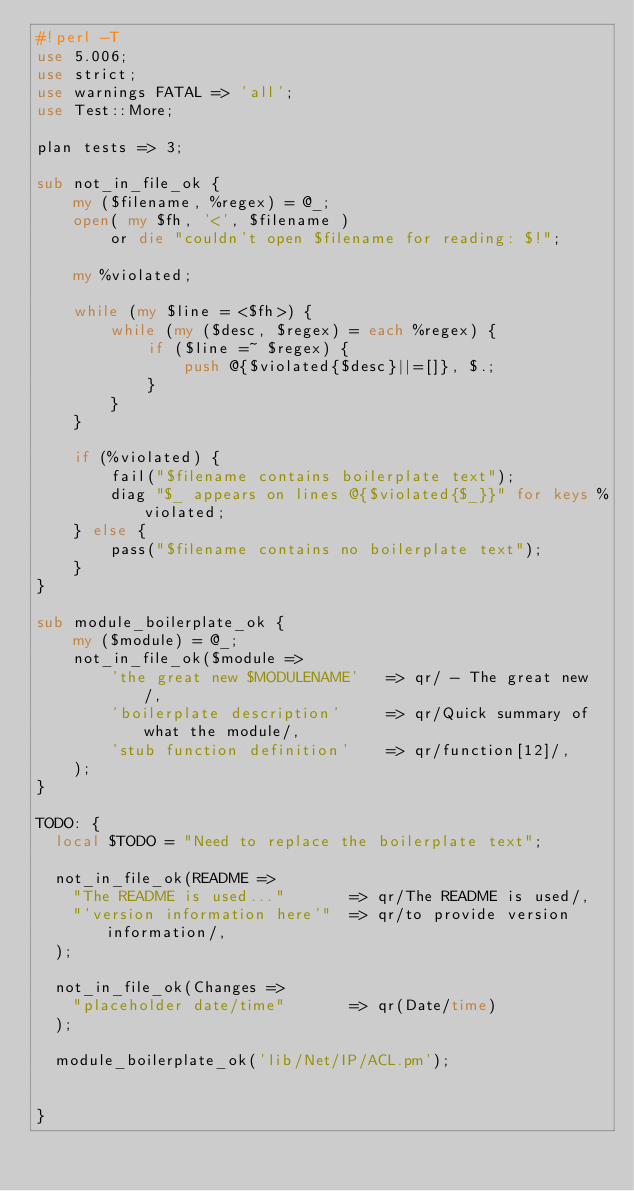<code> <loc_0><loc_0><loc_500><loc_500><_Perl_>#!perl -T
use 5.006;
use strict;
use warnings FATAL => 'all';
use Test::More;

plan tests => 3;

sub not_in_file_ok {
    my ($filename, %regex) = @_;
    open( my $fh, '<', $filename )
        or die "couldn't open $filename for reading: $!";

    my %violated;

    while (my $line = <$fh>) {
        while (my ($desc, $regex) = each %regex) {
            if ($line =~ $regex) {
                push @{$violated{$desc}||=[]}, $.;
            }
        }
    }

    if (%violated) {
        fail("$filename contains boilerplate text");
        diag "$_ appears on lines @{$violated{$_}}" for keys %violated;
    } else {
        pass("$filename contains no boilerplate text");
    }
}

sub module_boilerplate_ok {
    my ($module) = @_;
    not_in_file_ok($module =>
        'the great new $MODULENAME'   => qr/ - The great new /,
        'boilerplate description'     => qr/Quick summary of what the module/,
        'stub function definition'    => qr/function[12]/,
    );
}

TODO: {
  local $TODO = "Need to replace the boilerplate text";

  not_in_file_ok(README =>
    "The README is used..."       => qr/The README is used/,
    "'version information here'"  => qr/to provide version information/,
  );

  not_in_file_ok(Changes =>
    "placeholder date/time"       => qr(Date/time)
  );

  module_boilerplate_ok('lib/Net/IP/ACL.pm');


}

</code> 